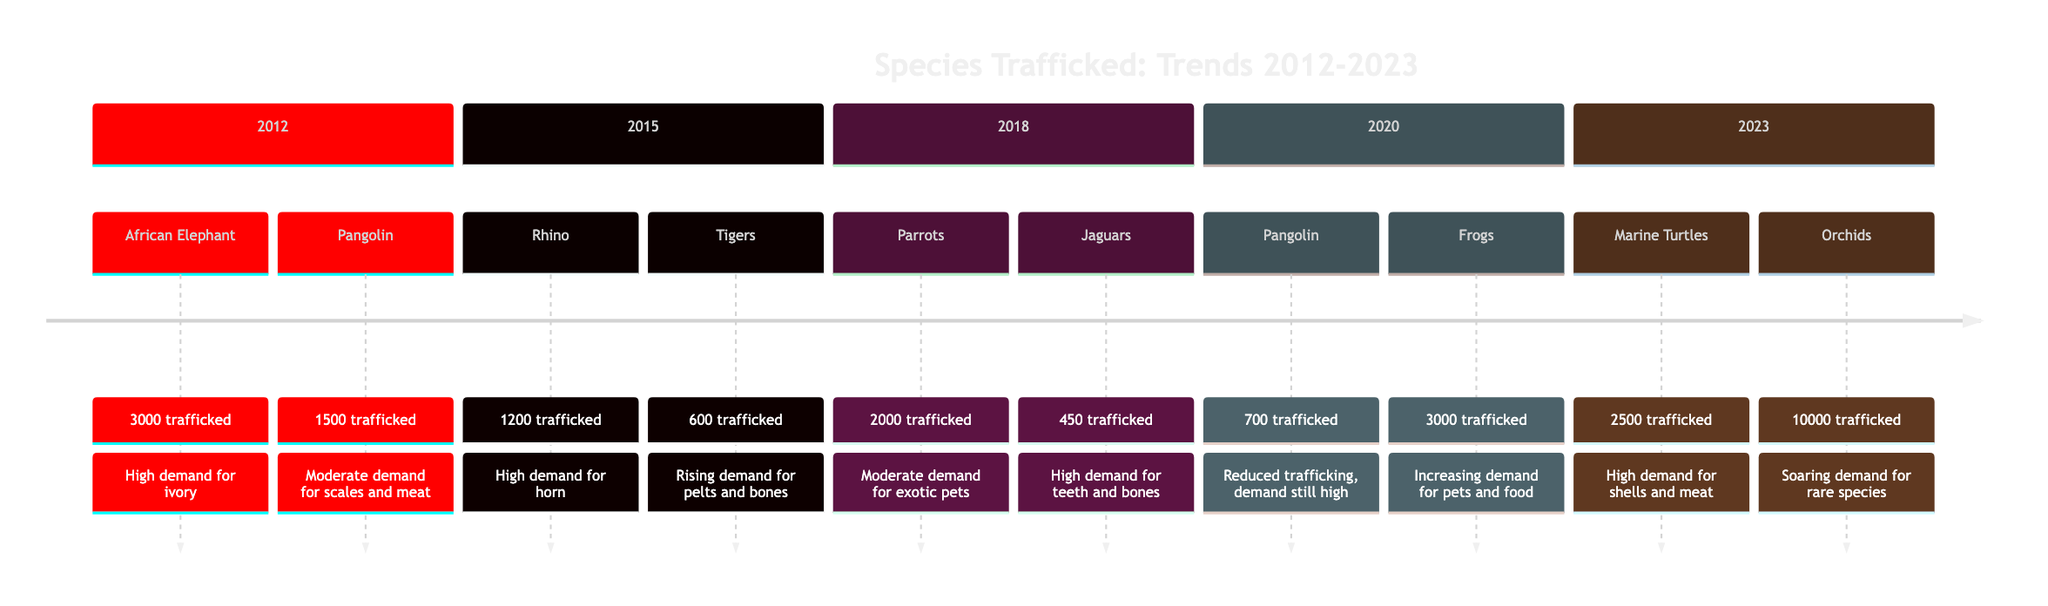What species was trafficked the most in 2023? In 2023, the diagram shows that Orchids were trafficked the most, with a quantity of 10,000 mentioned in the section for that year.
Answer: Orchids How many African Elephants were trafficked in 2012? The diagram states that 3,000 African Elephants were trafficked in 2012, as indicated in the section dedicated to that year.
Answer: 3000 Which species experienced the highest quantity of trafficking in 2020? According to the timeline for 2020, Frogs had the highest quantity of trafficking at 3,000, as noted in the events for that year.
Answer: Frogs What has been the trend in Pangolin trafficking from 2012 to 2020? The timeline reveals that Pangolin trafficking was 1,500 in 2012, decreased to 700 by 2020 due to global crackdowns, but market demand remained high. This shows a downward trend in trafficking numbers despite sustained demand.
Answer: Decreasing What species had a high market demand but a moderate quantity trafficked in 2020? In 2020, the diagram shows that while Pangolins had moderate trafficking quantities (700), the market demand was still categorized as high.
Answer: Pangolin How many species were trafficked in 2015? The diagram indicates that two species were trafficked in 2015, specifically referring to Rhinos and Tigers in the section for that year.
Answer: 2 Which species saw an increase in trafficking from 2018 to 2023? A comparison of the data indicates that Marine Turtles, trafficked in 2023 with 2,500 units, illustrates growth compared to the earlier figures in 2018 when no marine turtles were mentioned.
Answer: Marine Turtles What was the trend in the demand for Orchids from 2020 to 2023? The timeline shows that Orchids saw a "soaring" demand in 2023, indicating a significant increase compared to previous years, culminating in a sharp rise in trafficking quantities.
Answer: Soaring How many Jaguars were trafficked in 2018? The section for 2018 specifies that 450 Jaguars were trafficked during that year.
Answer: 450 